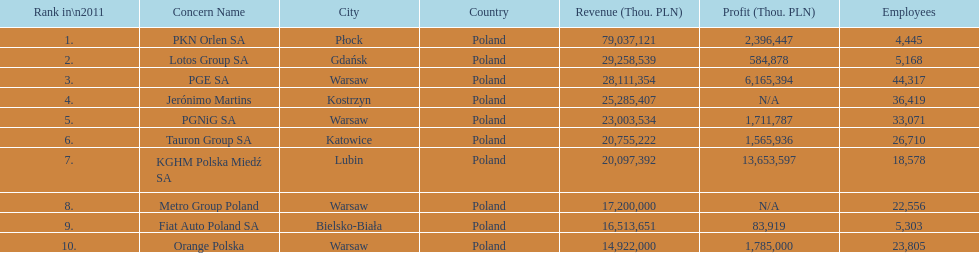How many companies had over $1,000,000 profit? 6. Help me parse the entirety of this table. {'header': ['Rank in\\n2011', 'Concern Name', 'City', 'Country', 'Revenue (Thou. PLN)', 'Profit (Thou. PLN)', 'Employees'], 'rows': [['1.', 'PKN Orlen SA', 'Płock', 'Poland', '79,037,121', '2,396,447', '4,445'], ['2.', 'Lotos Group SA', 'Gdańsk', 'Poland', '29,258,539', '584,878', '5,168'], ['3.', 'PGE SA', 'Warsaw', 'Poland', '28,111,354', '6,165,394', '44,317'], ['4.', 'Jerónimo Martins', 'Kostrzyn', 'Poland', '25,285,407', 'N/A', '36,419'], ['5.', 'PGNiG SA', 'Warsaw', 'Poland', '23,003,534', '1,711,787', '33,071'], ['6.', 'Tauron Group SA', 'Katowice', 'Poland', '20,755,222', '1,565,936', '26,710'], ['7.', 'KGHM Polska Miedź SA', 'Lubin', 'Poland', '20,097,392', '13,653,597', '18,578'], ['8.', 'Metro Group Poland', 'Warsaw', 'Poland', '17,200,000', 'N/A', '22,556'], ['9.', 'Fiat Auto Poland SA', 'Bielsko-Biała', 'Poland', '16,513,651', '83,919', '5,303'], ['10.', 'Orange Polska', 'Warsaw', 'Poland', '14,922,000', '1,785,000', '23,805']]} 